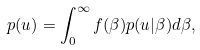Convert formula to latex. <formula><loc_0><loc_0><loc_500><loc_500>p ( u ) = \int _ { 0 } ^ { \infty } f ( \beta ) p ( u | \beta ) d \beta ,</formula> 